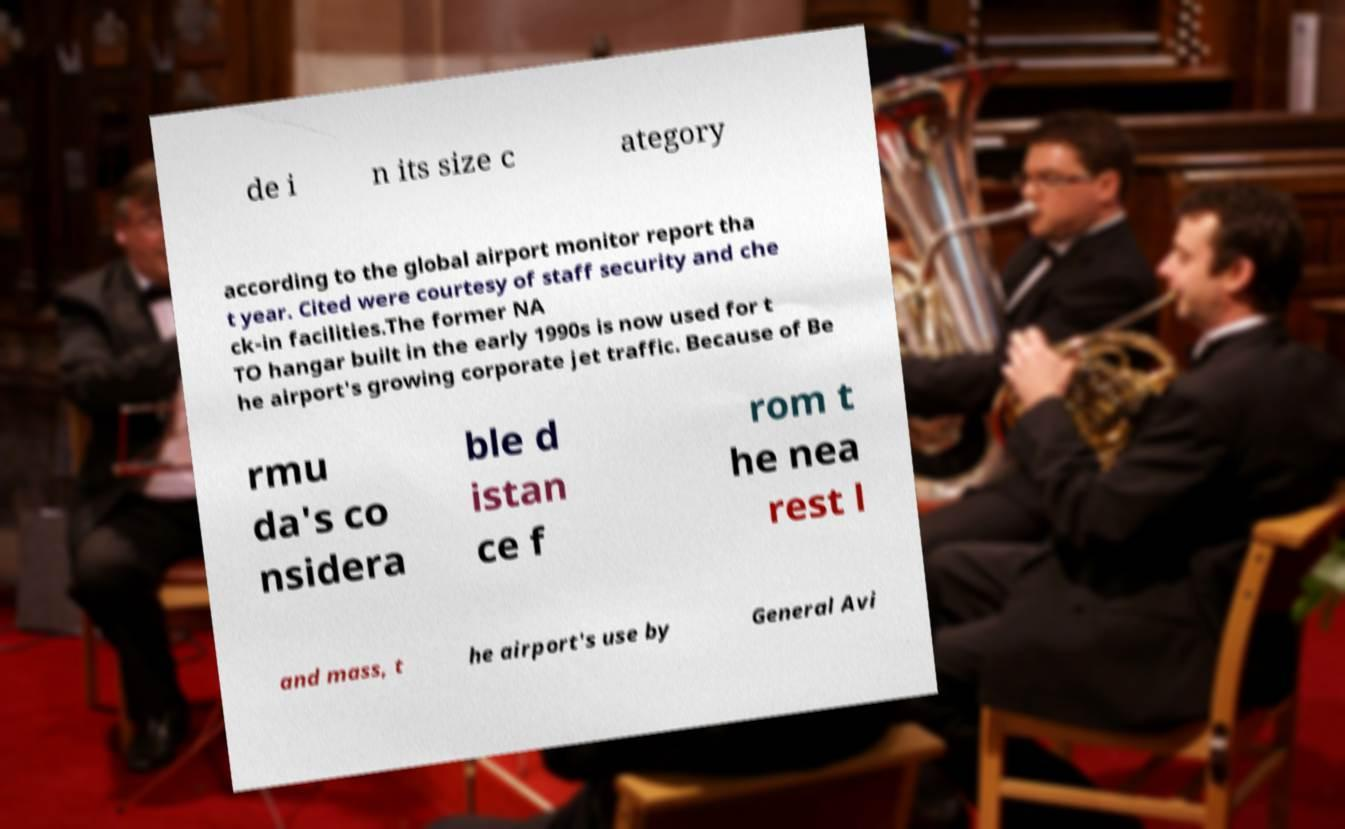What messages or text are displayed in this image? I need them in a readable, typed format. de i n its size c ategory according to the global airport monitor report tha t year. Cited were courtesy of staff security and che ck-in facilities.The former NA TO hangar built in the early 1990s is now used for t he airport's growing corporate jet traffic. Because of Be rmu da's co nsidera ble d istan ce f rom t he nea rest l and mass, t he airport's use by General Avi 